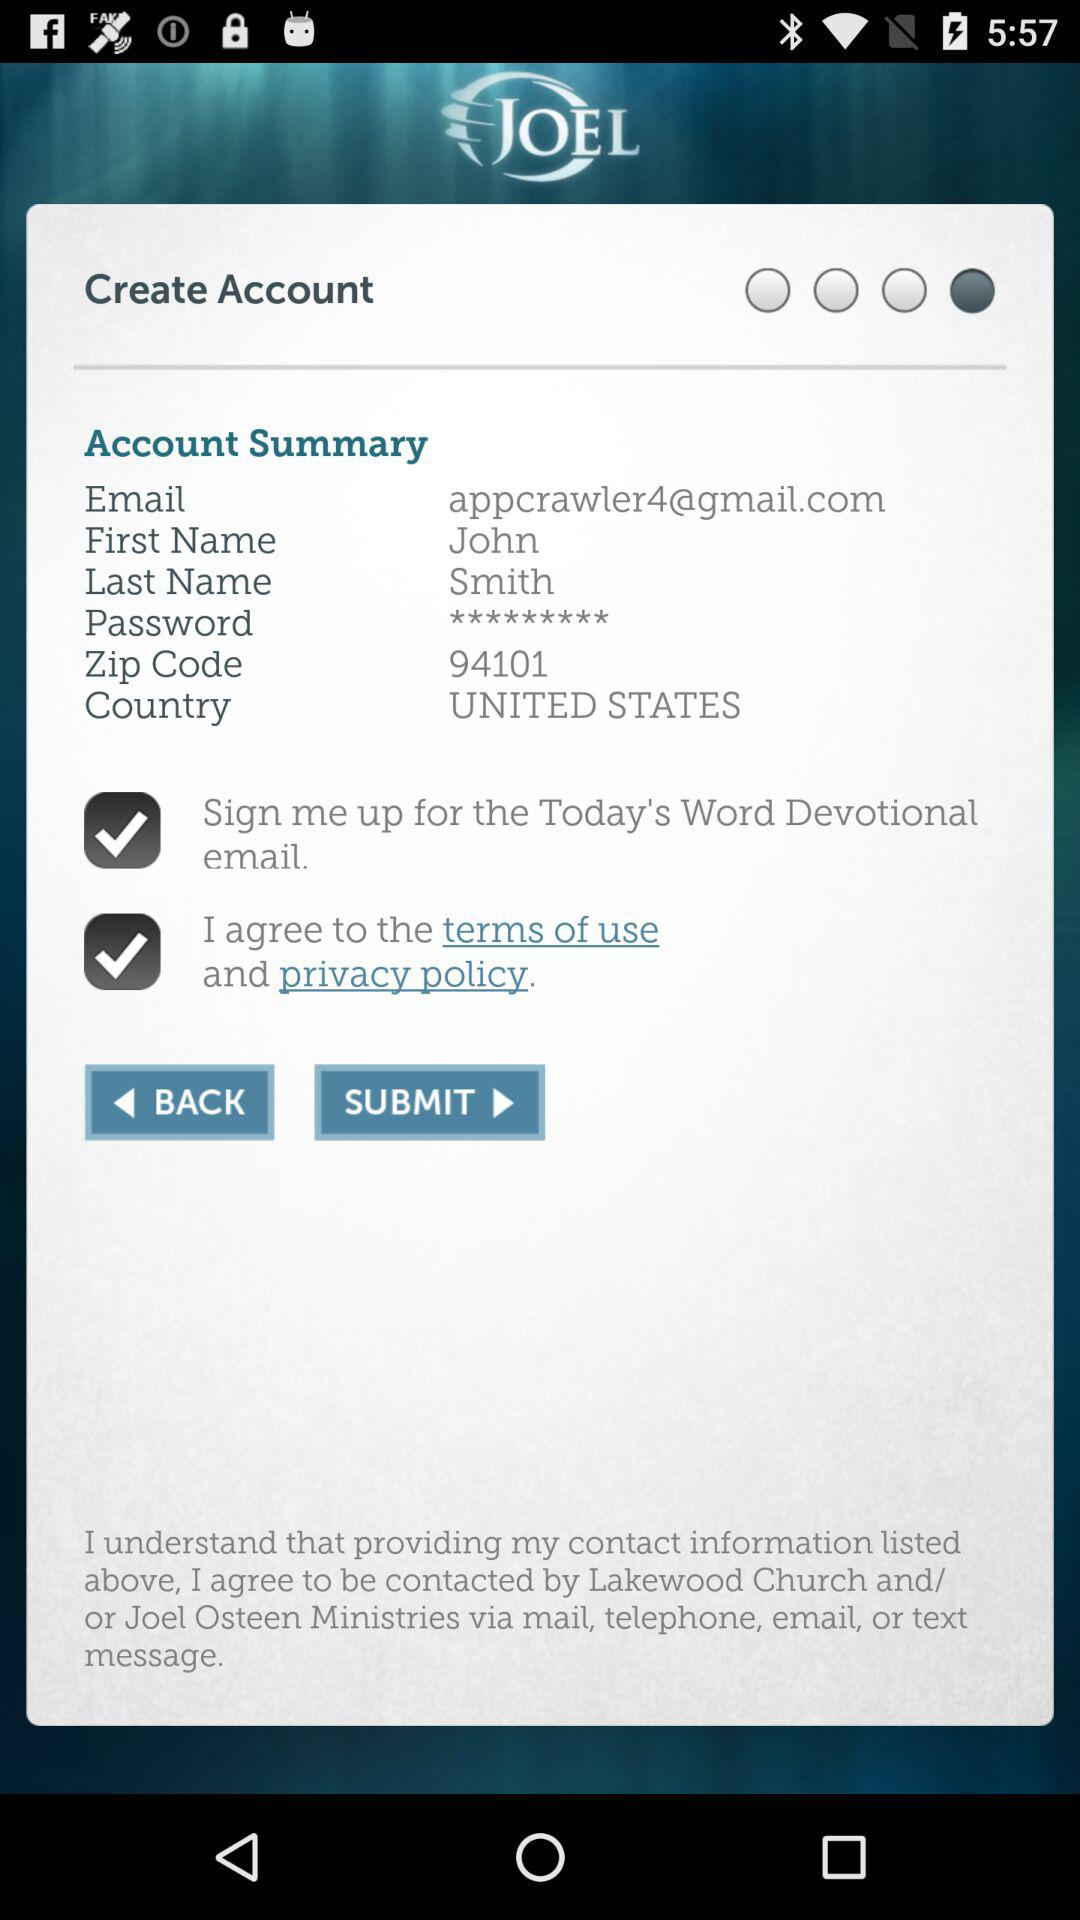What is the zip code? The zip code is 94101. 